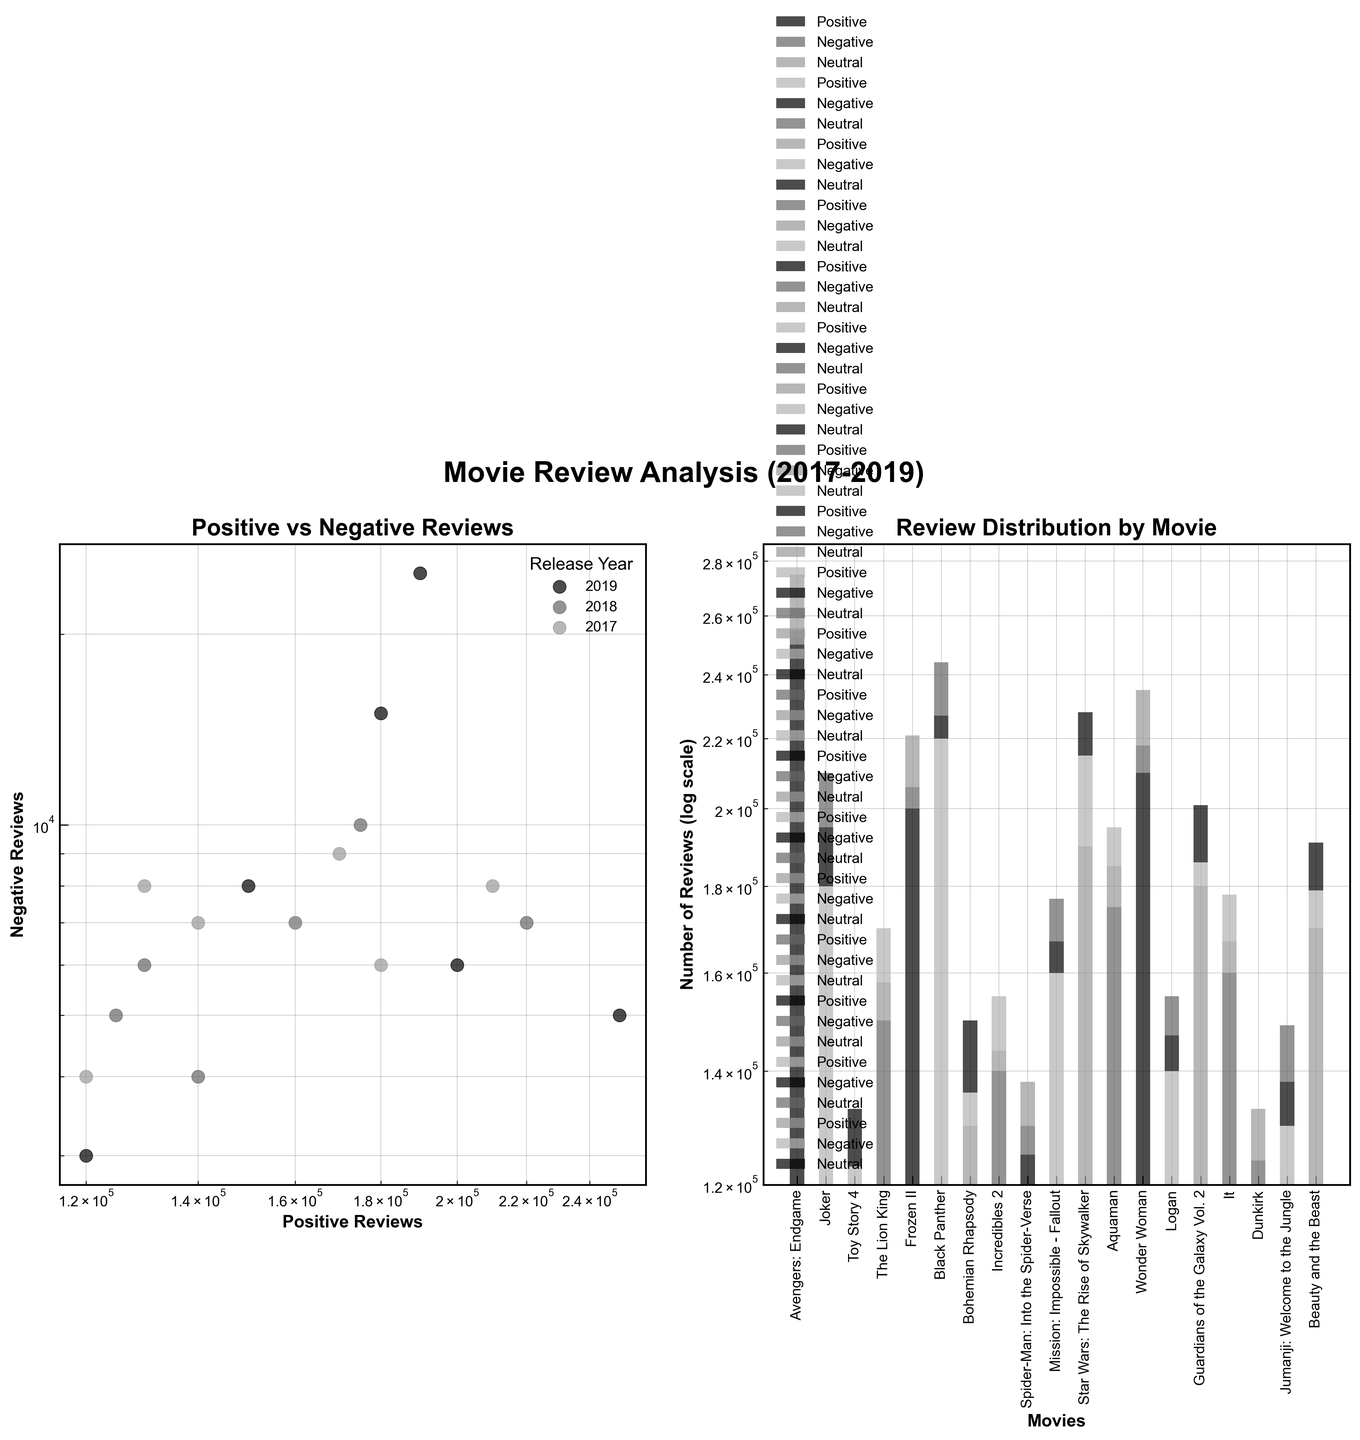How many movies' reviews are analyzed in the plot? By counting the number of bars in the second subplot, we find that there are 19 movies reviewed.
Answer: 19 What is the title of the first subplot? By looking at the title above the first subplot, we can see that it is "Positive vs Negative Reviews."
Answer: Positive vs Negative Reviews Which movie has the highest number of positive reviews? By looking at the height of the bars representing positive reviews in the second subplot, "Avengers: Endgame" has the tallest bar, indicating the highest number of positive reviews.
Answer: Avengers: Endgame What is the approximate ratio of positive to negative reviews for "Star Wars: The Rise of Skywalker"? "Star Wars: The Rise of Skywalker" has approximately 190,000 positive reviews and 25,000 negative reviews. The ratio is 190,000:25,000, which simplifies to approximately 7.6:1.
Answer: 7.6:1 Which year appears to have the movie with the least number of negative reviews? By looking at the position of the points in the first subplot, the movie "Toy Story 4" in 2019 has the least negative reviews with around 3,000.
Answer: 2019 Compare the number of positive reviews for "Jumanji: Welcome to the Jungle" and "Incredibles 2." Which one has more? By looking at the heights of the bars in the second subplot, "Incredibles 2" has about 140,000 positive reviews whereas "Jumanji: Welcome to the Jungle" has about 130,000 positive reviews. "Incredibles 2" has more positive reviews.
Answer: Incredibles 2 Identify two movies released in 2018 with similar numbers of negative reviews. By observing the first subplot and looking for 2018 movies, both "Black Panther" and "Mission: Impossible - Fallout" have similar negative reviews around 7,000.
Answer: Black Panther, Mission: Impossible - Fallout Which movie from 2017 has accumulated the most neutral reviews? By inspecting the second subplot, "Beauty and the Beast" from 2017 has the tallest bar segment for neutral reviews indicating the highest number of neutral reviews among the 2017 movies.
Answer: Beauty and the Beast What percentage of "Frozen II" reviews are positive? "Frozen II" has 200,000 positive reviews, 6,000 negative reviews, and 15,000 neutral reviews. The total number of reviews is 200,000 + 6,000 + 15,000 = 221,000. The percentage of positive reviews is (200,000 / 221,000) * 100 ≈ 90.5%.
Answer: 90.5% Which movie has a higher number of neutral reviews: "Guardians of the Galaxy Vol. 2" or "Logan"? By comparing the bars in the second subplot, "Guardians of the Galaxy Vol. 2" has about 15,000 neutral reviews, whereas "Logan" has about 8,000 neutral reviews.
Answer: Guardians of the Galaxy Vol. 2 